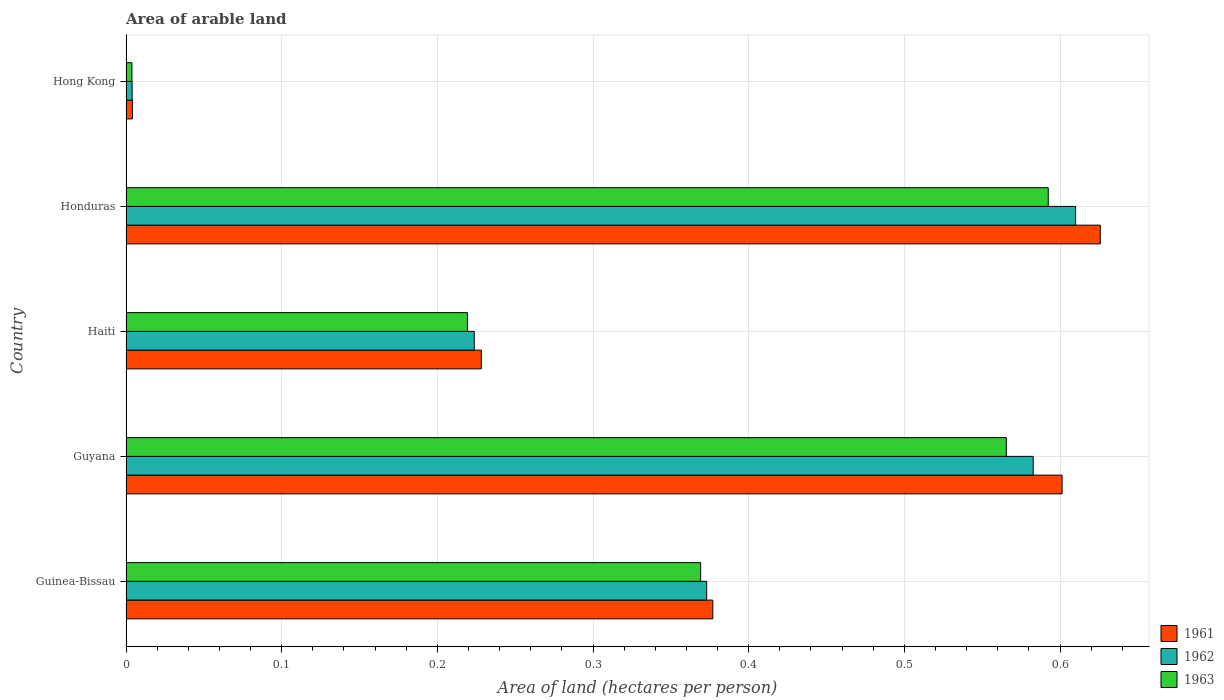How many groups of bars are there?
Offer a very short reply. 5. Are the number of bars per tick equal to the number of legend labels?
Offer a very short reply. Yes. How many bars are there on the 2nd tick from the bottom?
Give a very brief answer. 3. What is the label of the 1st group of bars from the top?
Give a very brief answer. Hong Kong. In how many cases, is the number of bars for a given country not equal to the number of legend labels?
Your response must be concise. 0. What is the total arable land in 1961 in Honduras?
Your answer should be very brief. 0.63. Across all countries, what is the maximum total arable land in 1962?
Keep it short and to the point. 0.61. Across all countries, what is the minimum total arable land in 1962?
Your answer should be very brief. 0. In which country was the total arable land in 1961 maximum?
Your answer should be very brief. Honduras. In which country was the total arable land in 1961 minimum?
Keep it short and to the point. Hong Kong. What is the total total arable land in 1962 in the graph?
Keep it short and to the point. 1.79. What is the difference between the total arable land in 1962 in Honduras and that in Hong Kong?
Your answer should be very brief. 0.61. What is the difference between the total arable land in 1962 in Hong Kong and the total arable land in 1963 in Guinea-Bissau?
Provide a succinct answer. -0.37. What is the average total arable land in 1961 per country?
Your answer should be compact. 0.37. What is the difference between the total arable land in 1961 and total arable land in 1962 in Honduras?
Offer a very short reply. 0.02. In how many countries, is the total arable land in 1963 greater than 0.38000000000000006 hectares per person?
Provide a succinct answer. 2. What is the ratio of the total arable land in 1961 in Guyana to that in Honduras?
Your response must be concise. 0.96. Is the total arable land in 1962 in Guyana less than that in Honduras?
Make the answer very short. Yes. Is the difference between the total arable land in 1961 in Haiti and Hong Kong greater than the difference between the total arable land in 1962 in Haiti and Hong Kong?
Your answer should be very brief. Yes. What is the difference between the highest and the second highest total arable land in 1963?
Your answer should be very brief. 0.03. What is the difference between the highest and the lowest total arable land in 1963?
Ensure brevity in your answer.  0.59. In how many countries, is the total arable land in 1962 greater than the average total arable land in 1962 taken over all countries?
Provide a succinct answer. 3. Is the sum of the total arable land in 1961 in Guinea-Bissau and Haiti greater than the maximum total arable land in 1963 across all countries?
Your response must be concise. Yes. What does the 2nd bar from the bottom in Honduras represents?
Offer a very short reply. 1962. Are all the bars in the graph horizontal?
Ensure brevity in your answer.  Yes. How many countries are there in the graph?
Ensure brevity in your answer.  5. Are the values on the major ticks of X-axis written in scientific E-notation?
Offer a terse response. No. Does the graph contain any zero values?
Make the answer very short. No. Where does the legend appear in the graph?
Keep it short and to the point. Bottom right. How many legend labels are there?
Keep it short and to the point. 3. What is the title of the graph?
Your answer should be very brief. Area of arable land. Does "2006" appear as one of the legend labels in the graph?
Your answer should be compact. No. What is the label or title of the X-axis?
Ensure brevity in your answer.  Area of land (hectares per person). What is the Area of land (hectares per person) in 1961 in Guinea-Bissau?
Make the answer very short. 0.38. What is the Area of land (hectares per person) of 1962 in Guinea-Bissau?
Your answer should be compact. 0.37. What is the Area of land (hectares per person) of 1963 in Guinea-Bissau?
Ensure brevity in your answer.  0.37. What is the Area of land (hectares per person) of 1961 in Guyana?
Your answer should be compact. 0.6. What is the Area of land (hectares per person) of 1962 in Guyana?
Give a very brief answer. 0.58. What is the Area of land (hectares per person) of 1963 in Guyana?
Your response must be concise. 0.57. What is the Area of land (hectares per person) of 1961 in Haiti?
Offer a terse response. 0.23. What is the Area of land (hectares per person) of 1962 in Haiti?
Your answer should be compact. 0.22. What is the Area of land (hectares per person) of 1963 in Haiti?
Provide a succinct answer. 0.22. What is the Area of land (hectares per person) of 1961 in Honduras?
Give a very brief answer. 0.63. What is the Area of land (hectares per person) in 1962 in Honduras?
Keep it short and to the point. 0.61. What is the Area of land (hectares per person) of 1963 in Honduras?
Offer a very short reply. 0.59. What is the Area of land (hectares per person) of 1961 in Hong Kong?
Keep it short and to the point. 0. What is the Area of land (hectares per person) in 1962 in Hong Kong?
Offer a terse response. 0. What is the Area of land (hectares per person) in 1963 in Hong Kong?
Offer a terse response. 0. Across all countries, what is the maximum Area of land (hectares per person) of 1961?
Your answer should be compact. 0.63. Across all countries, what is the maximum Area of land (hectares per person) in 1962?
Provide a succinct answer. 0.61. Across all countries, what is the maximum Area of land (hectares per person) of 1963?
Offer a very short reply. 0.59. Across all countries, what is the minimum Area of land (hectares per person) in 1961?
Make the answer very short. 0. Across all countries, what is the minimum Area of land (hectares per person) in 1962?
Provide a succinct answer. 0. Across all countries, what is the minimum Area of land (hectares per person) of 1963?
Ensure brevity in your answer.  0. What is the total Area of land (hectares per person) in 1961 in the graph?
Offer a terse response. 1.84. What is the total Area of land (hectares per person) of 1962 in the graph?
Your response must be concise. 1.79. What is the total Area of land (hectares per person) of 1963 in the graph?
Provide a succinct answer. 1.75. What is the difference between the Area of land (hectares per person) in 1961 in Guinea-Bissau and that in Guyana?
Offer a very short reply. -0.22. What is the difference between the Area of land (hectares per person) of 1962 in Guinea-Bissau and that in Guyana?
Give a very brief answer. -0.21. What is the difference between the Area of land (hectares per person) of 1963 in Guinea-Bissau and that in Guyana?
Your answer should be compact. -0.2. What is the difference between the Area of land (hectares per person) in 1961 in Guinea-Bissau and that in Haiti?
Offer a terse response. 0.15. What is the difference between the Area of land (hectares per person) in 1962 in Guinea-Bissau and that in Haiti?
Provide a short and direct response. 0.15. What is the difference between the Area of land (hectares per person) in 1963 in Guinea-Bissau and that in Haiti?
Offer a terse response. 0.15. What is the difference between the Area of land (hectares per person) in 1961 in Guinea-Bissau and that in Honduras?
Keep it short and to the point. -0.25. What is the difference between the Area of land (hectares per person) of 1962 in Guinea-Bissau and that in Honduras?
Your answer should be very brief. -0.24. What is the difference between the Area of land (hectares per person) in 1963 in Guinea-Bissau and that in Honduras?
Your answer should be very brief. -0.22. What is the difference between the Area of land (hectares per person) in 1961 in Guinea-Bissau and that in Hong Kong?
Make the answer very short. 0.37. What is the difference between the Area of land (hectares per person) in 1962 in Guinea-Bissau and that in Hong Kong?
Ensure brevity in your answer.  0.37. What is the difference between the Area of land (hectares per person) of 1963 in Guinea-Bissau and that in Hong Kong?
Keep it short and to the point. 0.37. What is the difference between the Area of land (hectares per person) of 1961 in Guyana and that in Haiti?
Your answer should be compact. 0.37. What is the difference between the Area of land (hectares per person) in 1962 in Guyana and that in Haiti?
Keep it short and to the point. 0.36. What is the difference between the Area of land (hectares per person) of 1963 in Guyana and that in Haiti?
Keep it short and to the point. 0.35. What is the difference between the Area of land (hectares per person) of 1961 in Guyana and that in Honduras?
Offer a very short reply. -0.02. What is the difference between the Area of land (hectares per person) in 1962 in Guyana and that in Honduras?
Your answer should be compact. -0.03. What is the difference between the Area of land (hectares per person) of 1963 in Guyana and that in Honduras?
Keep it short and to the point. -0.03. What is the difference between the Area of land (hectares per person) in 1961 in Guyana and that in Hong Kong?
Keep it short and to the point. 0.6. What is the difference between the Area of land (hectares per person) of 1962 in Guyana and that in Hong Kong?
Provide a succinct answer. 0.58. What is the difference between the Area of land (hectares per person) of 1963 in Guyana and that in Hong Kong?
Your response must be concise. 0.56. What is the difference between the Area of land (hectares per person) of 1961 in Haiti and that in Honduras?
Ensure brevity in your answer.  -0.4. What is the difference between the Area of land (hectares per person) in 1962 in Haiti and that in Honduras?
Make the answer very short. -0.39. What is the difference between the Area of land (hectares per person) in 1963 in Haiti and that in Honduras?
Provide a succinct answer. -0.37. What is the difference between the Area of land (hectares per person) of 1961 in Haiti and that in Hong Kong?
Provide a short and direct response. 0.22. What is the difference between the Area of land (hectares per person) of 1962 in Haiti and that in Hong Kong?
Your answer should be very brief. 0.22. What is the difference between the Area of land (hectares per person) in 1963 in Haiti and that in Hong Kong?
Your answer should be compact. 0.22. What is the difference between the Area of land (hectares per person) of 1961 in Honduras and that in Hong Kong?
Your answer should be compact. 0.62. What is the difference between the Area of land (hectares per person) of 1962 in Honduras and that in Hong Kong?
Offer a very short reply. 0.61. What is the difference between the Area of land (hectares per person) in 1963 in Honduras and that in Hong Kong?
Your answer should be compact. 0.59. What is the difference between the Area of land (hectares per person) in 1961 in Guinea-Bissau and the Area of land (hectares per person) in 1962 in Guyana?
Make the answer very short. -0.21. What is the difference between the Area of land (hectares per person) of 1961 in Guinea-Bissau and the Area of land (hectares per person) of 1963 in Guyana?
Your response must be concise. -0.19. What is the difference between the Area of land (hectares per person) in 1962 in Guinea-Bissau and the Area of land (hectares per person) in 1963 in Guyana?
Offer a very short reply. -0.19. What is the difference between the Area of land (hectares per person) of 1961 in Guinea-Bissau and the Area of land (hectares per person) of 1962 in Haiti?
Your response must be concise. 0.15. What is the difference between the Area of land (hectares per person) in 1961 in Guinea-Bissau and the Area of land (hectares per person) in 1963 in Haiti?
Provide a succinct answer. 0.16. What is the difference between the Area of land (hectares per person) of 1962 in Guinea-Bissau and the Area of land (hectares per person) of 1963 in Haiti?
Your response must be concise. 0.15. What is the difference between the Area of land (hectares per person) of 1961 in Guinea-Bissau and the Area of land (hectares per person) of 1962 in Honduras?
Give a very brief answer. -0.23. What is the difference between the Area of land (hectares per person) in 1961 in Guinea-Bissau and the Area of land (hectares per person) in 1963 in Honduras?
Your response must be concise. -0.22. What is the difference between the Area of land (hectares per person) of 1962 in Guinea-Bissau and the Area of land (hectares per person) of 1963 in Honduras?
Provide a short and direct response. -0.22. What is the difference between the Area of land (hectares per person) in 1961 in Guinea-Bissau and the Area of land (hectares per person) in 1962 in Hong Kong?
Your response must be concise. 0.37. What is the difference between the Area of land (hectares per person) of 1961 in Guinea-Bissau and the Area of land (hectares per person) of 1963 in Hong Kong?
Your answer should be compact. 0.37. What is the difference between the Area of land (hectares per person) of 1962 in Guinea-Bissau and the Area of land (hectares per person) of 1963 in Hong Kong?
Your answer should be compact. 0.37. What is the difference between the Area of land (hectares per person) in 1961 in Guyana and the Area of land (hectares per person) in 1962 in Haiti?
Your answer should be very brief. 0.38. What is the difference between the Area of land (hectares per person) of 1961 in Guyana and the Area of land (hectares per person) of 1963 in Haiti?
Ensure brevity in your answer.  0.38. What is the difference between the Area of land (hectares per person) of 1962 in Guyana and the Area of land (hectares per person) of 1963 in Haiti?
Give a very brief answer. 0.36. What is the difference between the Area of land (hectares per person) in 1961 in Guyana and the Area of land (hectares per person) in 1962 in Honduras?
Your answer should be compact. -0.01. What is the difference between the Area of land (hectares per person) in 1961 in Guyana and the Area of land (hectares per person) in 1963 in Honduras?
Ensure brevity in your answer.  0.01. What is the difference between the Area of land (hectares per person) in 1962 in Guyana and the Area of land (hectares per person) in 1963 in Honduras?
Offer a very short reply. -0.01. What is the difference between the Area of land (hectares per person) in 1961 in Guyana and the Area of land (hectares per person) in 1962 in Hong Kong?
Your response must be concise. 0.6. What is the difference between the Area of land (hectares per person) in 1961 in Guyana and the Area of land (hectares per person) in 1963 in Hong Kong?
Provide a short and direct response. 0.6. What is the difference between the Area of land (hectares per person) in 1962 in Guyana and the Area of land (hectares per person) in 1963 in Hong Kong?
Offer a terse response. 0.58. What is the difference between the Area of land (hectares per person) of 1961 in Haiti and the Area of land (hectares per person) of 1962 in Honduras?
Make the answer very short. -0.38. What is the difference between the Area of land (hectares per person) in 1961 in Haiti and the Area of land (hectares per person) in 1963 in Honduras?
Provide a succinct answer. -0.36. What is the difference between the Area of land (hectares per person) in 1962 in Haiti and the Area of land (hectares per person) in 1963 in Honduras?
Your answer should be compact. -0.37. What is the difference between the Area of land (hectares per person) of 1961 in Haiti and the Area of land (hectares per person) of 1962 in Hong Kong?
Your response must be concise. 0.22. What is the difference between the Area of land (hectares per person) of 1961 in Haiti and the Area of land (hectares per person) of 1963 in Hong Kong?
Your answer should be very brief. 0.22. What is the difference between the Area of land (hectares per person) in 1962 in Haiti and the Area of land (hectares per person) in 1963 in Hong Kong?
Your answer should be compact. 0.22. What is the difference between the Area of land (hectares per person) in 1961 in Honduras and the Area of land (hectares per person) in 1962 in Hong Kong?
Your answer should be very brief. 0.62. What is the difference between the Area of land (hectares per person) in 1961 in Honduras and the Area of land (hectares per person) in 1963 in Hong Kong?
Provide a short and direct response. 0.62. What is the difference between the Area of land (hectares per person) in 1962 in Honduras and the Area of land (hectares per person) in 1963 in Hong Kong?
Offer a terse response. 0.61. What is the average Area of land (hectares per person) of 1961 per country?
Make the answer very short. 0.37. What is the average Area of land (hectares per person) in 1962 per country?
Offer a terse response. 0.36. What is the average Area of land (hectares per person) in 1963 per country?
Keep it short and to the point. 0.35. What is the difference between the Area of land (hectares per person) of 1961 and Area of land (hectares per person) of 1962 in Guinea-Bissau?
Ensure brevity in your answer.  0. What is the difference between the Area of land (hectares per person) of 1961 and Area of land (hectares per person) of 1963 in Guinea-Bissau?
Your response must be concise. 0.01. What is the difference between the Area of land (hectares per person) of 1962 and Area of land (hectares per person) of 1963 in Guinea-Bissau?
Make the answer very short. 0. What is the difference between the Area of land (hectares per person) in 1961 and Area of land (hectares per person) in 1962 in Guyana?
Make the answer very short. 0.02. What is the difference between the Area of land (hectares per person) in 1961 and Area of land (hectares per person) in 1963 in Guyana?
Your answer should be compact. 0.04. What is the difference between the Area of land (hectares per person) of 1962 and Area of land (hectares per person) of 1963 in Guyana?
Offer a very short reply. 0.02. What is the difference between the Area of land (hectares per person) of 1961 and Area of land (hectares per person) of 1962 in Haiti?
Your answer should be compact. 0. What is the difference between the Area of land (hectares per person) in 1961 and Area of land (hectares per person) in 1963 in Haiti?
Keep it short and to the point. 0.01. What is the difference between the Area of land (hectares per person) in 1962 and Area of land (hectares per person) in 1963 in Haiti?
Your answer should be compact. 0. What is the difference between the Area of land (hectares per person) in 1961 and Area of land (hectares per person) in 1962 in Honduras?
Provide a short and direct response. 0.02. What is the difference between the Area of land (hectares per person) in 1961 and Area of land (hectares per person) in 1963 in Honduras?
Provide a succinct answer. 0.03. What is the difference between the Area of land (hectares per person) of 1962 and Area of land (hectares per person) of 1963 in Honduras?
Offer a very short reply. 0.02. What is the difference between the Area of land (hectares per person) of 1961 and Area of land (hectares per person) of 1963 in Hong Kong?
Provide a succinct answer. 0. What is the ratio of the Area of land (hectares per person) of 1961 in Guinea-Bissau to that in Guyana?
Your response must be concise. 0.63. What is the ratio of the Area of land (hectares per person) of 1962 in Guinea-Bissau to that in Guyana?
Provide a short and direct response. 0.64. What is the ratio of the Area of land (hectares per person) in 1963 in Guinea-Bissau to that in Guyana?
Keep it short and to the point. 0.65. What is the ratio of the Area of land (hectares per person) of 1961 in Guinea-Bissau to that in Haiti?
Offer a very short reply. 1.65. What is the ratio of the Area of land (hectares per person) of 1962 in Guinea-Bissau to that in Haiti?
Your answer should be compact. 1.67. What is the ratio of the Area of land (hectares per person) of 1963 in Guinea-Bissau to that in Haiti?
Your answer should be very brief. 1.68. What is the ratio of the Area of land (hectares per person) in 1961 in Guinea-Bissau to that in Honduras?
Give a very brief answer. 0.6. What is the ratio of the Area of land (hectares per person) of 1962 in Guinea-Bissau to that in Honduras?
Make the answer very short. 0.61. What is the ratio of the Area of land (hectares per person) in 1963 in Guinea-Bissau to that in Honduras?
Your answer should be very brief. 0.62. What is the ratio of the Area of land (hectares per person) in 1961 in Guinea-Bissau to that in Hong Kong?
Provide a succinct answer. 91.86. What is the ratio of the Area of land (hectares per person) in 1962 in Guinea-Bissau to that in Hong Kong?
Make the answer very short. 94.84. What is the ratio of the Area of land (hectares per person) of 1963 in Guinea-Bissau to that in Hong Kong?
Make the answer very short. 97.14. What is the ratio of the Area of land (hectares per person) of 1961 in Guyana to that in Haiti?
Your answer should be very brief. 2.63. What is the ratio of the Area of land (hectares per person) in 1962 in Guyana to that in Haiti?
Offer a terse response. 2.6. What is the ratio of the Area of land (hectares per person) of 1963 in Guyana to that in Haiti?
Offer a very short reply. 2.58. What is the ratio of the Area of land (hectares per person) of 1961 in Guyana to that in Honduras?
Make the answer very short. 0.96. What is the ratio of the Area of land (hectares per person) in 1962 in Guyana to that in Honduras?
Give a very brief answer. 0.96. What is the ratio of the Area of land (hectares per person) of 1963 in Guyana to that in Honduras?
Give a very brief answer. 0.95. What is the ratio of the Area of land (hectares per person) of 1961 in Guyana to that in Hong Kong?
Give a very brief answer. 146.55. What is the ratio of the Area of land (hectares per person) in 1962 in Guyana to that in Hong Kong?
Give a very brief answer. 148.17. What is the ratio of the Area of land (hectares per person) of 1963 in Guyana to that in Hong Kong?
Ensure brevity in your answer.  148.82. What is the ratio of the Area of land (hectares per person) of 1961 in Haiti to that in Honduras?
Provide a short and direct response. 0.36. What is the ratio of the Area of land (hectares per person) in 1962 in Haiti to that in Honduras?
Offer a very short reply. 0.37. What is the ratio of the Area of land (hectares per person) of 1963 in Haiti to that in Honduras?
Your response must be concise. 0.37. What is the ratio of the Area of land (hectares per person) of 1961 in Haiti to that in Hong Kong?
Your answer should be compact. 55.62. What is the ratio of the Area of land (hectares per person) of 1962 in Haiti to that in Hong Kong?
Offer a very short reply. 56.88. What is the ratio of the Area of land (hectares per person) of 1963 in Haiti to that in Hong Kong?
Provide a succinct answer. 57.71. What is the ratio of the Area of land (hectares per person) in 1961 in Honduras to that in Hong Kong?
Offer a very short reply. 152.53. What is the ratio of the Area of land (hectares per person) of 1962 in Honduras to that in Hong Kong?
Offer a very short reply. 155.1. What is the ratio of the Area of land (hectares per person) in 1963 in Honduras to that in Hong Kong?
Offer a terse response. 155.9. What is the difference between the highest and the second highest Area of land (hectares per person) in 1961?
Offer a terse response. 0.02. What is the difference between the highest and the second highest Area of land (hectares per person) of 1962?
Offer a terse response. 0.03. What is the difference between the highest and the second highest Area of land (hectares per person) of 1963?
Provide a succinct answer. 0.03. What is the difference between the highest and the lowest Area of land (hectares per person) in 1961?
Ensure brevity in your answer.  0.62. What is the difference between the highest and the lowest Area of land (hectares per person) in 1962?
Your response must be concise. 0.61. What is the difference between the highest and the lowest Area of land (hectares per person) of 1963?
Provide a short and direct response. 0.59. 